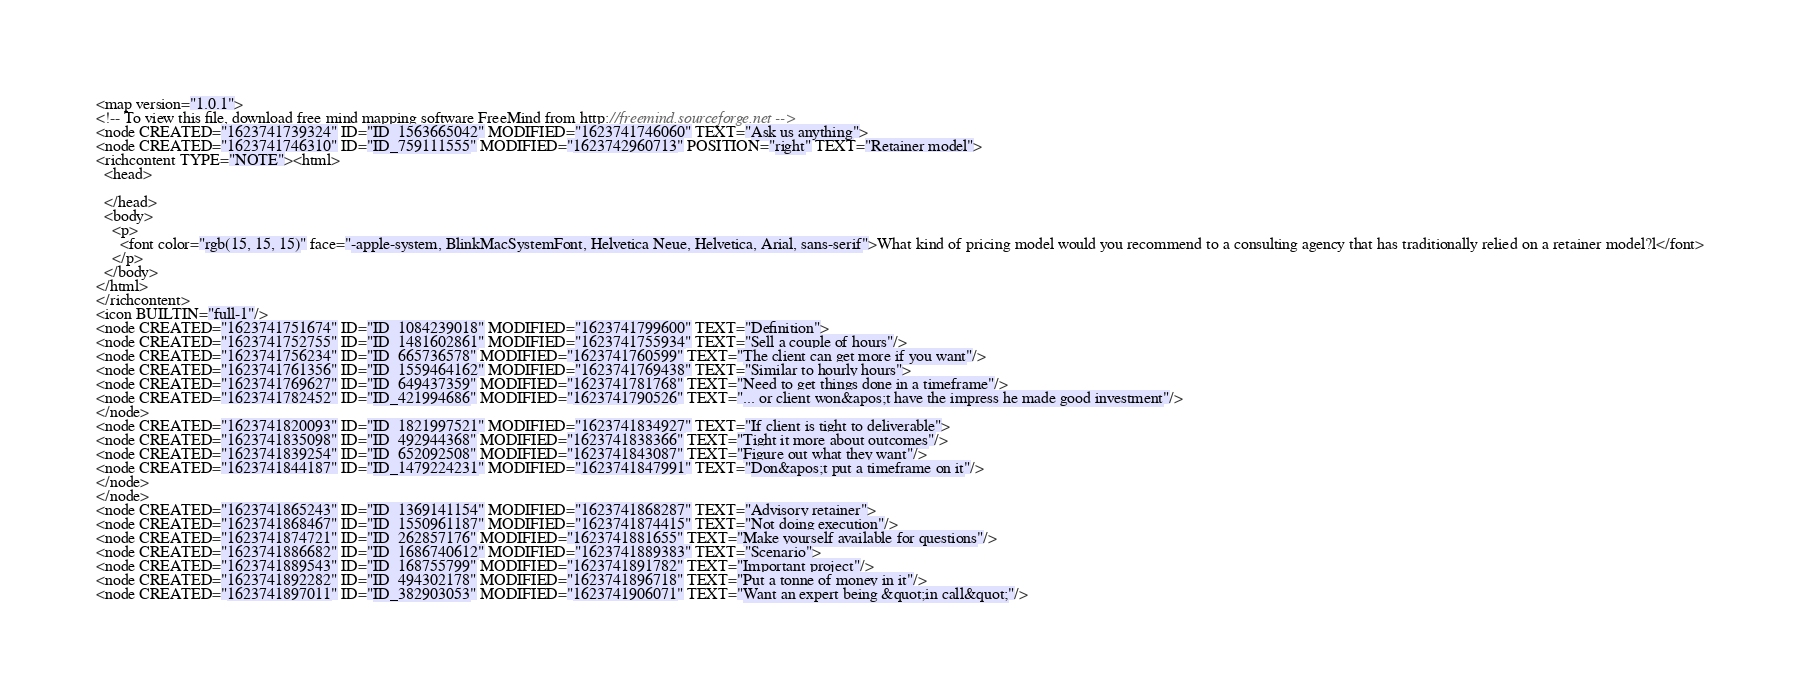<code> <loc_0><loc_0><loc_500><loc_500><_ObjectiveC_><map version="1.0.1">
<!-- To view this file, download free mind mapping software FreeMind from http://freemind.sourceforge.net -->
<node CREATED="1623741739324" ID="ID_1563665042" MODIFIED="1623741746060" TEXT="Ask us anything">
<node CREATED="1623741746310" ID="ID_759111555" MODIFIED="1623742960713" POSITION="right" TEXT="Retainer model">
<richcontent TYPE="NOTE"><html>
  <head>
    
  </head>
  <body>
    <p>
      <font color="rgb(15, 15, 15)" face="-apple-system, BlinkMacSystemFont, Helvetica Neue, Helvetica, Arial, sans-serif">What kind of pricing model would you recommend to a consulting agency that has traditionally relied on a retainer model?l</font>
    </p>
  </body>
</html>
</richcontent>
<icon BUILTIN="full-1"/>
<node CREATED="1623741751674" ID="ID_1084239018" MODIFIED="1623741799600" TEXT="Definition">
<node CREATED="1623741752755" ID="ID_1481602861" MODIFIED="1623741755934" TEXT="Sell a couple of hours"/>
<node CREATED="1623741756234" ID="ID_665736578" MODIFIED="1623741760599" TEXT="The client can get more if you want"/>
<node CREATED="1623741761356" ID="ID_1559464162" MODIFIED="1623741769438" TEXT="Similar to hourly hours">
<node CREATED="1623741769627" ID="ID_649437359" MODIFIED="1623741781768" TEXT="Need to get things done in a timeframe"/>
<node CREATED="1623741782452" ID="ID_421994686" MODIFIED="1623741790526" TEXT="... or client won&apos;t have the impress he made good investment"/>
</node>
<node CREATED="1623741820093" ID="ID_1821997521" MODIFIED="1623741834927" TEXT="If client is tight to deliverable">
<node CREATED="1623741835098" ID="ID_492944368" MODIFIED="1623741838366" TEXT="Tight it more about outcomes"/>
<node CREATED="1623741839254" ID="ID_652092508" MODIFIED="1623741843087" TEXT="Figure out what they want"/>
<node CREATED="1623741844187" ID="ID_1479224231" MODIFIED="1623741847991" TEXT="Don&apos;t put a timeframe on it"/>
</node>
</node>
<node CREATED="1623741865243" ID="ID_1369141154" MODIFIED="1623741868287" TEXT="Advisory retainer">
<node CREATED="1623741868467" ID="ID_1550961187" MODIFIED="1623741874415" TEXT="Not doing execution"/>
<node CREATED="1623741874721" ID="ID_262857176" MODIFIED="1623741881655" TEXT="Make yourself available for questions"/>
<node CREATED="1623741886682" ID="ID_1686740612" MODIFIED="1623741889383" TEXT="Scenario">
<node CREATED="1623741889543" ID="ID_168755799" MODIFIED="1623741891782" TEXT="Important project"/>
<node CREATED="1623741892282" ID="ID_494302178" MODIFIED="1623741896718" TEXT="Put a tonne of money in it"/>
<node CREATED="1623741897011" ID="ID_382903053" MODIFIED="1623741906071" TEXT="Want an expert being &quot;in call&quot;"/></code> 